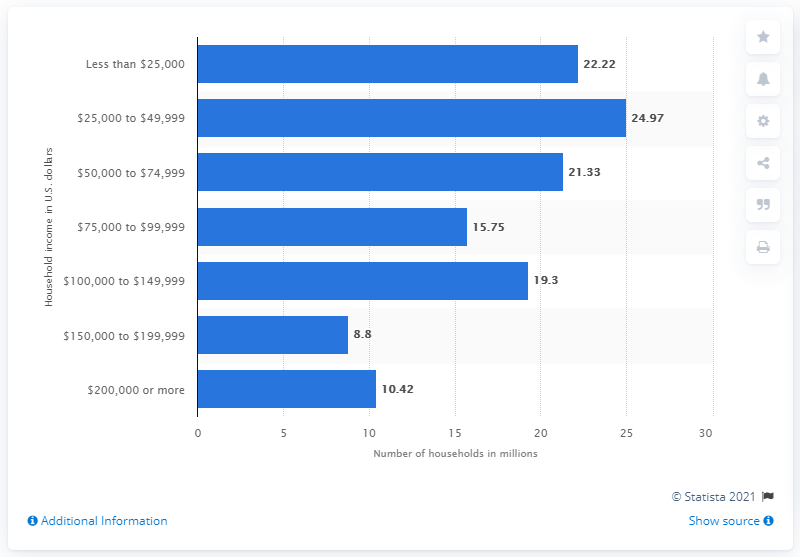Identify some key points in this picture. In 2019, there were approximately 10.42 households in the United States that had an annual income of $200,000 or more. 